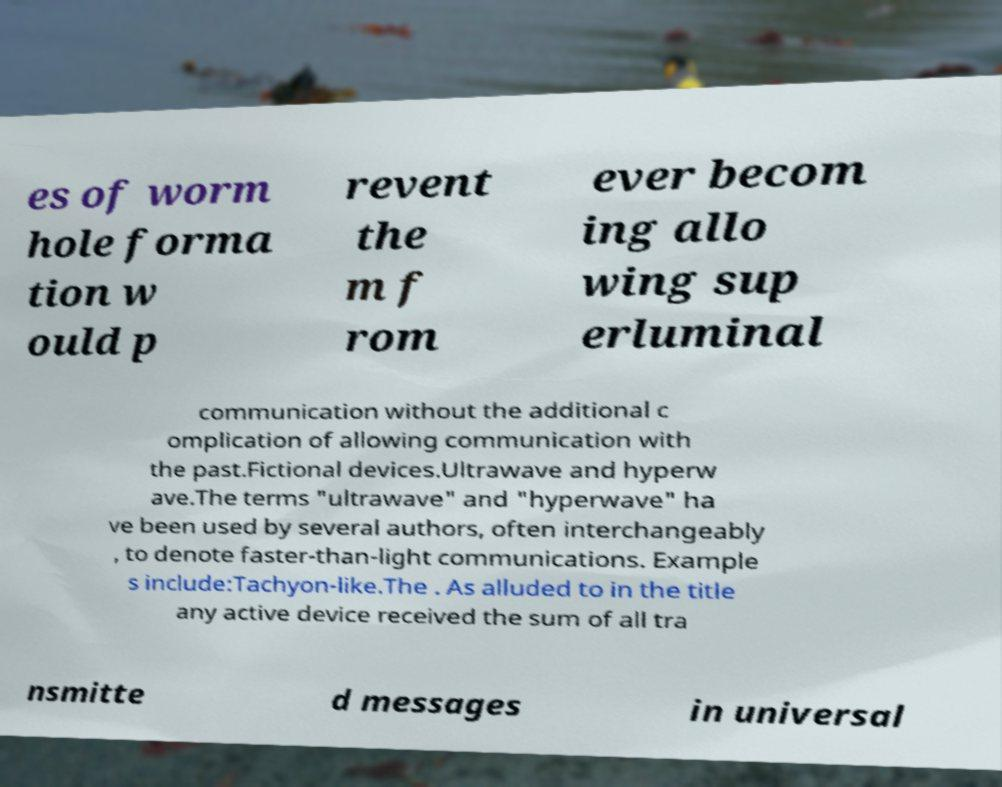There's text embedded in this image that I need extracted. Can you transcribe it verbatim? es of worm hole forma tion w ould p revent the m f rom ever becom ing allo wing sup erluminal communication without the additional c omplication of allowing communication with the past.Fictional devices.Ultrawave and hyperw ave.The terms "ultrawave" and "hyperwave" ha ve been used by several authors, often interchangeably , to denote faster-than-light communications. Example s include:Tachyon-like.The . As alluded to in the title any active device received the sum of all tra nsmitte d messages in universal 